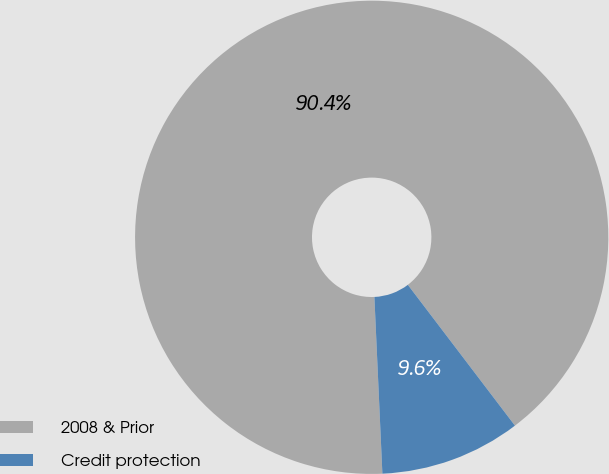Convert chart. <chart><loc_0><loc_0><loc_500><loc_500><pie_chart><fcel>2008 & Prior<fcel>Credit protection<nl><fcel>90.37%<fcel>9.63%<nl></chart> 